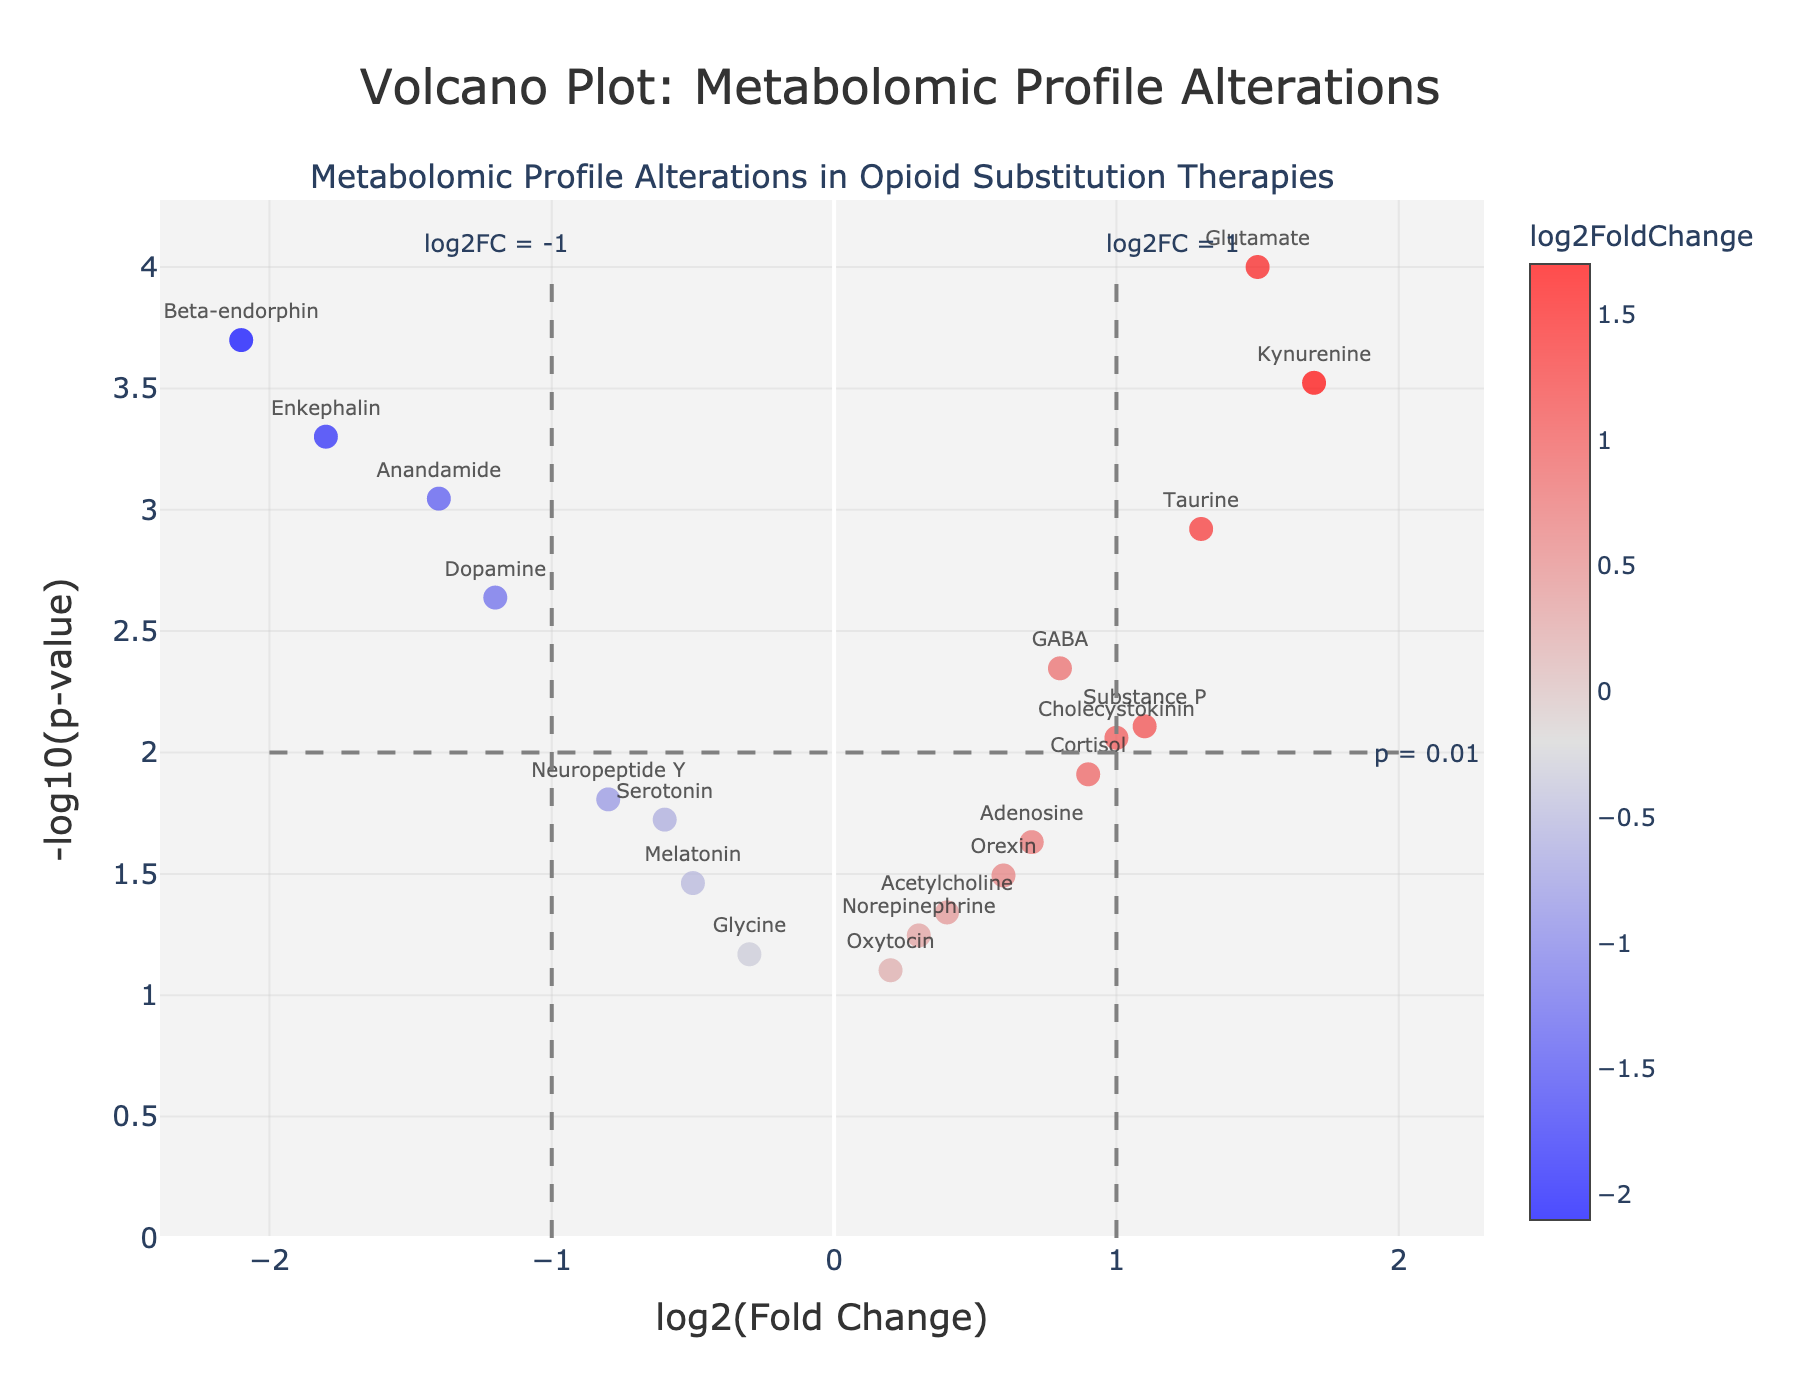What is the title of the plot? The title is prominently displayed at the top of the plot. It reads "Volcano Plot: Metabolomic Profile Alterations".
Answer: Volcano Plot: Metabolomic Profile Alterations Which metabolite has the highest -log10(p-value)? The metabolite with the highest -log10(p-value) will be the one located at the topmost position in the vertical axis.
Answer: Glutamate How many metabolites have a negative log2FoldChange? The metabolites with negative log2FoldChange will be located on the left side of the vertical axis (x-axis). By counting the data points on the left side, we find that there are 9 metabolites.
Answer: 9 What is the log2FoldChange and p-value of beta-endorphin? Locate beta-endorphin on the plot. According to the hovertext or the data, the log2FoldChange is -2.1 and the p-value is 0.0002.
Answer: log2FC: -2.1, p-value: 0.0002 Which metabolites have a log2FoldChange greater than 1? Look for metabolites situated to the right of the vertical threshold line at log2FC=1. These include Glutamate, Taurine, Kynurenine, and Substance P.
Answer: Glutamate, Taurine, Kynurenine, Substance P What threshold line value differentiates significant and non-significant p-values, and what is the corresponding -log10(p-value)? The horizontal threshold line usually indicates the p-value cutoff, at y=2, which corresponds to p=0.01.
Answer: p = 0.01, -log10(p-value) = 2 Which metabolite has the most significant negative alteration in metabolic profile? The most significant negative alteration is represented by the farthest point to the left with the highest -log10(p-value), which is Beta-endorphin.
Answer: Beta-endorphin Compare the log2FoldChange values of Dopamine and GABA. Which one has a greater alteration? Dopamine has a log2FoldChange of -1.2, and GABA has a log2FoldChange of 0.8. Comparing these values, GABA has the greater alteration in the positive direction.
Answer: GABA How many metabolites are considered statistically significant (p < 0.01)? Metabolites with a p-value < 0.01 stand above the horizontal threshold line at y=2. By counting these data points, we find that there are 8 significant metabolites.
Answer: 8 